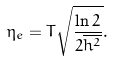<formula> <loc_0><loc_0><loc_500><loc_500>\eta _ { e } = T \sqrt { \frac { \ln 2 } { 2 \overline { h ^ { 2 } } } } .</formula> 